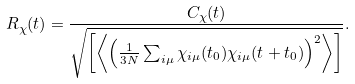<formula> <loc_0><loc_0><loc_500><loc_500>R _ { \chi } ( t ) = \frac { C _ { \chi } ( t ) } { \sqrt { \left [ \left \langle \left ( \frac { 1 } { 3 N } \sum _ { i \mu } \chi _ { i \mu } ( t _ { 0 } ) \chi _ { i \mu } ( t + t _ { 0 } ) \right ) ^ { 2 } \right \rangle \right ] } } .</formula> 